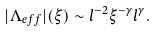<formula> <loc_0><loc_0><loc_500><loc_500>| \Lambda _ { e f f } | ( \xi ) \sim l ^ { - 2 } \xi ^ { - \gamma } l ^ { \gamma } .</formula> 